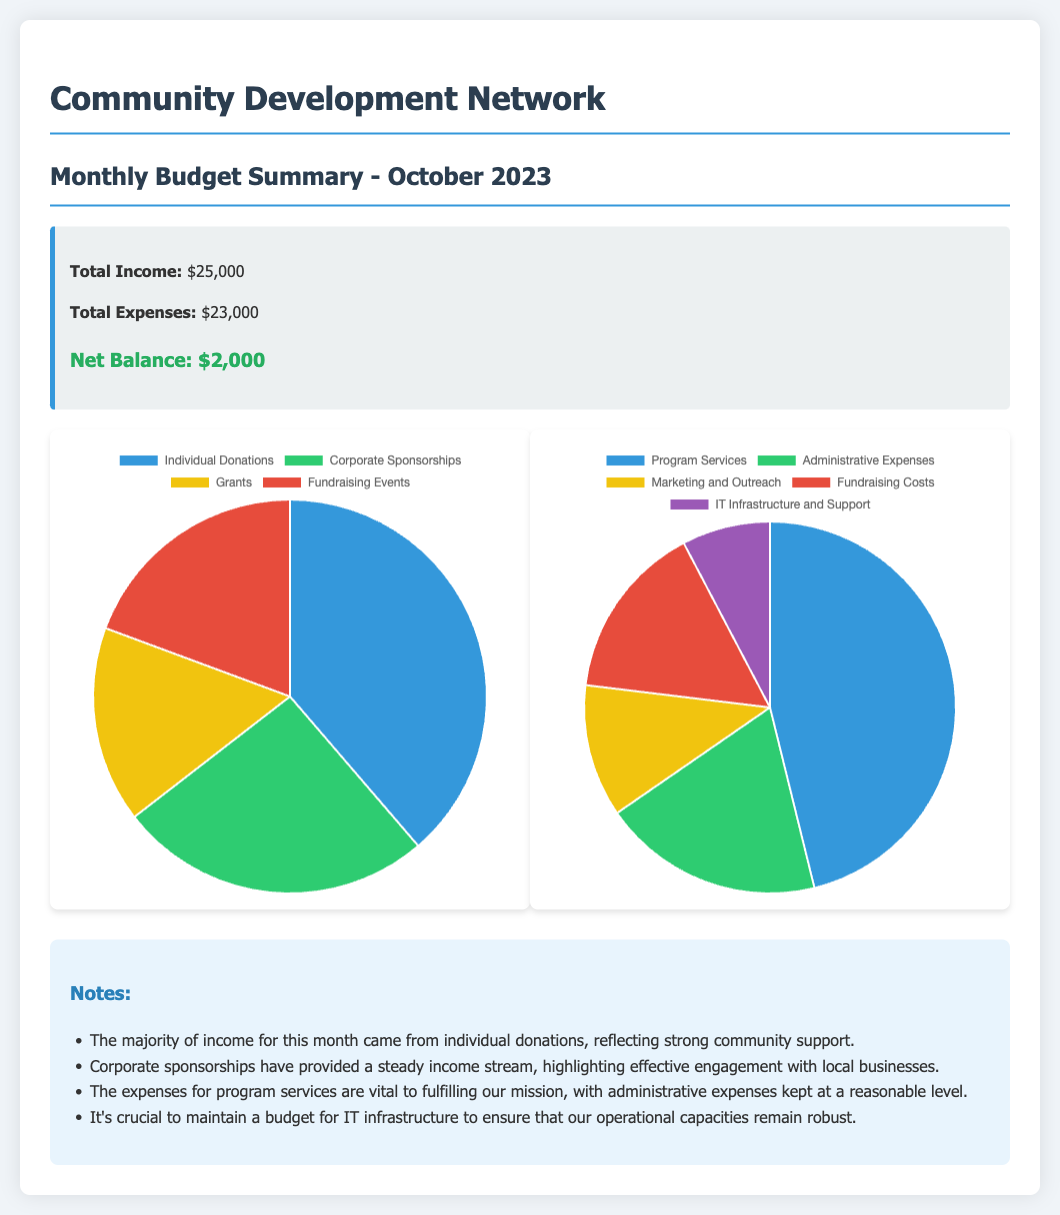What is the total income for October 2023? The total income is stated in the summary box of the document as $25,000.
Answer: $25,000 What is the total expense for October 2023? The total expense is mentioned in the summary box as $23,000.
Answer: $23,000 What is the net balance for October 2023? The net balance is indicated in the summary box as $2,000.
Answer: $2,000 Which income source generated the highest amount? The income chart shows that individual donations produced the highest income of $12,000.
Answer: Individual Donations What percentage of the total income comes from corporate sponsorships? Corporate sponsorships amount to $8,000, which can be determined as a part of the total income of $25,000, representing 32% of total income.
Answer: 32% What is the largest category of expenses? The expense chart indicates that program services accounted for the largest portion of expenses at $12,000.
Answer: Program Services How much was spent on IT infrastructure and support? The document mentions that $2,000 was specifically allocated for IT infrastructure and support.
Answer: $2,000 What kind of expenses are emphasized as necessary for fulfilling the organization's mission? The notes highlight that expenses for program services are vital for fulfilling the organization's mission.
Answer: Program Services What trend is observed in the income from individual donations? The document mentions a strong community support reflecting the trend of increased income from individual donations.
Answer: Strong community support 